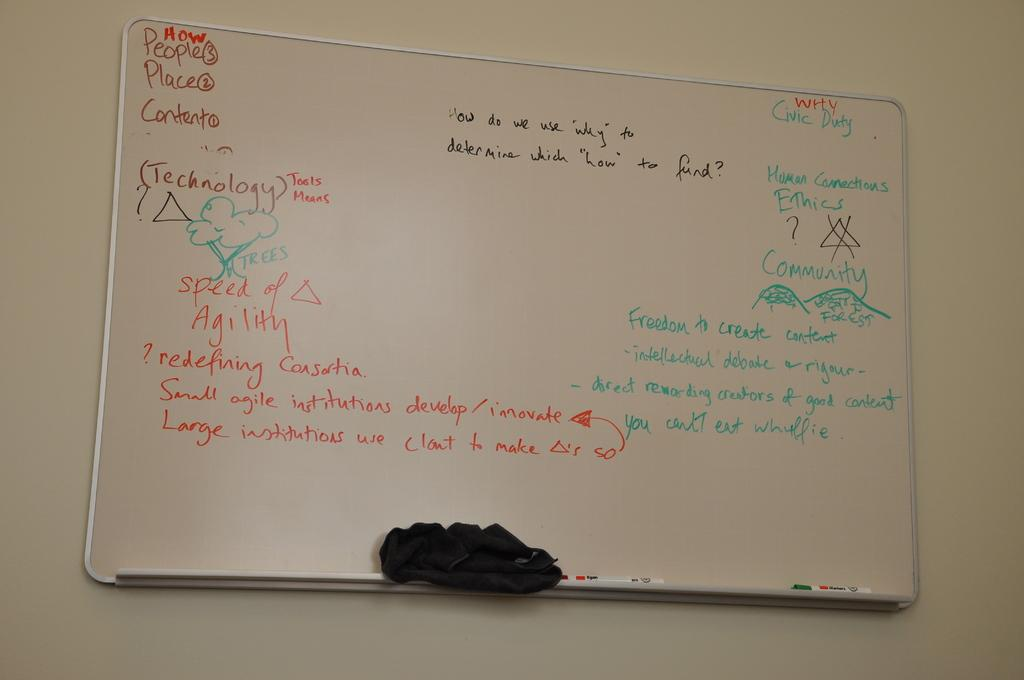What is on the wall in the image? There is a board on the wall in the image. What is written on the board? There is text written on the board. What color is the cloth on the board? The cloth on the board is black in color. What might be used for writing on the board? Pens are visible in the image, which might be used for writing on the board. What type of music can be heard playing from the bells in the image? There are no bells present in the image, so it is not possible to determine what type of music might be heard. 